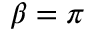Convert formula to latex. <formula><loc_0><loc_0><loc_500><loc_500>\beta = \pi</formula> 